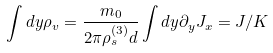Convert formula to latex. <formula><loc_0><loc_0><loc_500><loc_500>\int d y \rho _ { v } = \frac { m _ { 0 } } { 2 \pi \rho ^ { ( 3 ) } _ { s } d } \int d y \partial _ { y } J _ { x } = J / K</formula> 